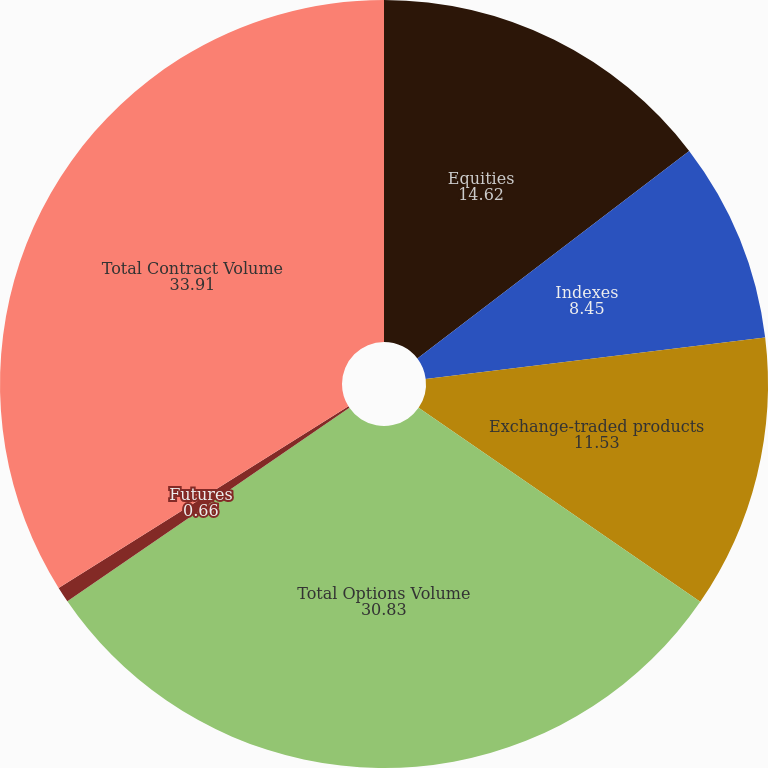Convert chart. <chart><loc_0><loc_0><loc_500><loc_500><pie_chart><fcel>Equities<fcel>Indexes<fcel>Exchange-traded products<fcel>Total Options Volume<fcel>Futures<fcel>Total Contract Volume<nl><fcel>14.62%<fcel>8.45%<fcel>11.53%<fcel>30.83%<fcel>0.66%<fcel>33.91%<nl></chart> 